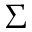<formula> <loc_0><loc_0><loc_500><loc_500>\Sigma</formula> 